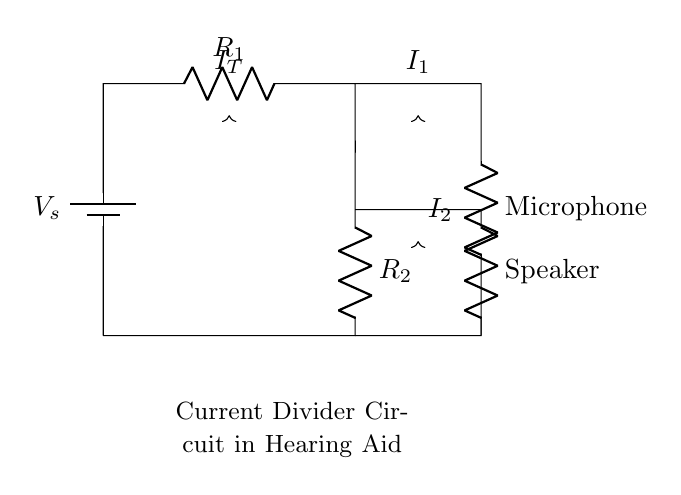What is the power source in this circuit? The power source in this circuit is denoted by the battery symbol, labeled as V_s.
Answer: V_s What components are involved in the current divider? The current divider circuit involves two resistors, R_1 and R_2, along with the microphone and speaker components.
Answer: R_1 and R_2 What is the total current entering the current divider? The total current entering the circuit is represented as I_T, which is shown at the top of the diagram.
Answer: I_T What is the relationship between R_1 and R_2 in terms of current distribution? The relationship is such that the currents I_1 and I_2 that flow through R_1 and R_2 are inversely proportional to their resistances. This means that a larger resistor has a smaller current and vice versa.
Answer: Inversely proportional If R_1 is 10 Ohms and R_2 is 20 Ohms, what is the ratio of the currents I_1 to I_2? The current ratio can be determined using the formula: I_1/I_2 = R_2/R_1. Therefore, I_1/I_2 = 20/10, which simplifies to 2.
Answer: 2 How does a current divider work in a hearing aid context? A current divider distributes the total current into the microphone and speaker, ensuring that both components receive power without affecting each other's performance. This allows for simultaneous operation.
Answer: Distributes power 